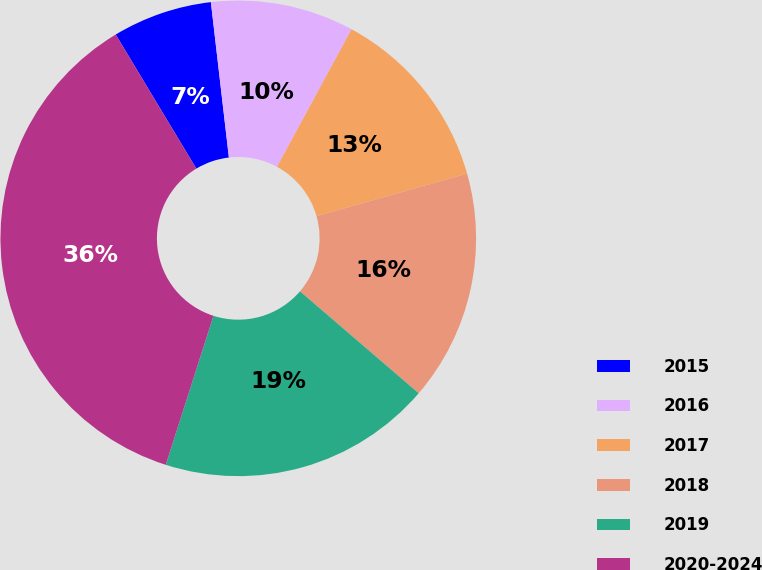Convert chart to OTSL. <chart><loc_0><loc_0><loc_500><loc_500><pie_chart><fcel>2015<fcel>2016<fcel>2017<fcel>2018<fcel>2019<fcel>2020-2024<nl><fcel>6.78%<fcel>9.74%<fcel>12.71%<fcel>15.68%<fcel>18.64%<fcel>36.45%<nl></chart> 